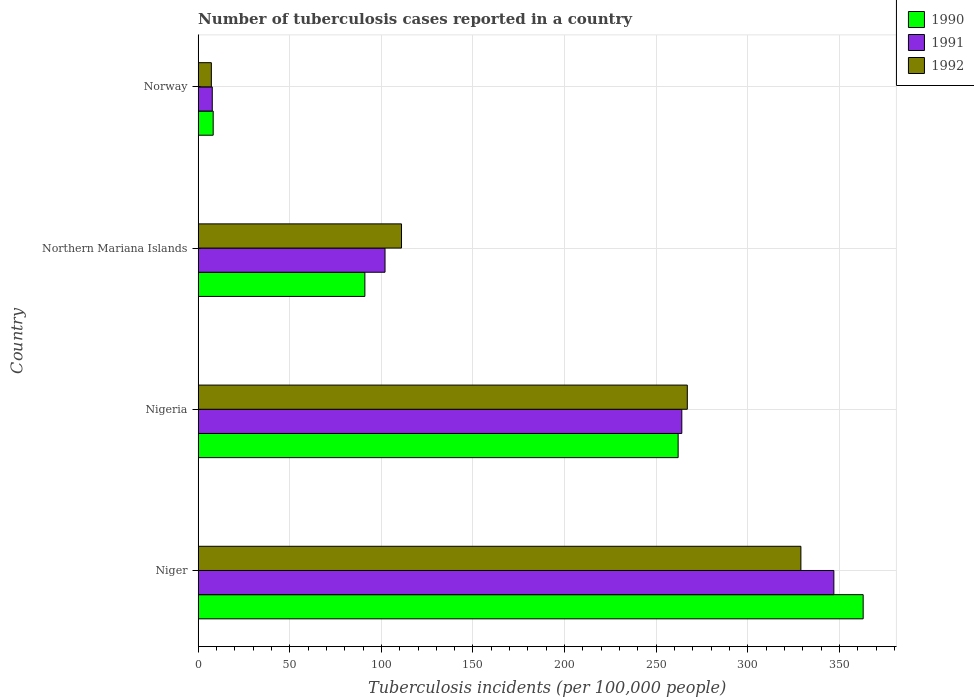How many different coloured bars are there?
Offer a very short reply. 3. Are the number of bars on each tick of the Y-axis equal?
Make the answer very short. Yes. How many bars are there on the 2nd tick from the top?
Offer a very short reply. 3. In how many cases, is the number of bars for a given country not equal to the number of legend labels?
Your response must be concise. 0. What is the number of tuberculosis cases reported in in 1990 in Niger?
Ensure brevity in your answer.  363. Across all countries, what is the maximum number of tuberculosis cases reported in in 1992?
Make the answer very short. 329. In which country was the number of tuberculosis cases reported in in 1992 maximum?
Your answer should be compact. Niger. What is the total number of tuberculosis cases reported in in 1991 in the graph?
Your answer should be very brief. 720.7. What is the difference between the number of tuberculosis cases reported in in 1990 in Northern Mariana Islands and that in Norway?
Offer a terse response. 82.8. What is the difference between the number of tuberculosis cases reported in in 1992 in Northern Mariana Islands and the number of tuberculosis cases reported in in 1990 in Norway?
Offer a very short reply. 102.8. What is the average number of tuberculosis cases reported in in 1990 per country?
Offer a very short reply. 181.05. In how many countries, is the number of tuberculosis cases reported in in 1991 greater than 260 ?
Make the answer very short. 2. What is the ratio of the number of tuberculosis cases reported in in 1990 in Nigeria to that in Northern Mariana Islands?
Offer a very short reply. 2.88. Is the number of tuberculosis cases reported in in 1992 in Nigeria less than that in Northern Mariana Islands?
Your answer should be very brief. No. What is the difference between the highest and the second highest number of tuberculosis cases reported in in 1992?
Your answer should be compact. 62. What is the difference between the highest and the lowest number of tuberculosis cases reported in in 1991?
Your answer should be compact. 339.3. Is the sum of the number of tuberculosis cases reported in in 1991 in Nigeria and Northern Mariana Islands greater than the maximum number of tuberculosis cases reported in in 1992 across all countries?
Keep it short and to the point. Yes. What does the 1st bar from the bottom in Norway represents?
Keep it short and to the point. 1990. How many bars are there?
Offer a terse response. 12. What is the difference between two consecutive major ticks on the X-axis?
Your response must be concise. 50. Does the graph contain any zero values?
Make the answer very short. No. Does the graph contain grids?
Provide a succinct answer. Yes. How many legend labels are there?
Provide a short and direct response. 3. What is the title of the graph?
Make the answer very short. Number of tuberculosis cases reported in a country. Does "2011" appear as one of the legend labels in the graph?
Keep it short and to the point. No. What is the label or title of the X-axis?
Provide a succinct answer. Tuberculosis incidents (per 100,0 people). What is the Tuberculosis incidents (per 100,000 people) of 1990 in Niger?
Ensure brevity in your answer.  363. What is the Tuberculosis incidents (per 100,000 people) of 1991 in Niger?
Keep it short and to the point. 347. What is the Tuberculosis incidents (per 100,000 people) in 1992 in Niger?
Provide a short and direct response. 329. What is the Tuberculosis incidents (per 100,000 people) in 1990 in Nigeria?
Your answer should be very brief. 262. What is the Tuberculosis incidents (per 100,000 people) of 1991 in Nigeria?
Keep it short and to the point. 264. What is the Tuberculosis incidents (per 100,000 people) in 1992 in Nigeria?
Your answer should be very brief. 267. What is the Tuberculosis incidents (per 100,000 people) in 1990 in Northern Mariana Islands?
Your answer should be compact. 91. What is the Tuberculosis incidents (per 100,000 people) in 1991 in Northern Mariana Islands?
Provide a short and direct response. 102. What is the Tuberculosis incidents (per 100,000 people) in 1992 in Northern Mariana Islands?
Keep it short and to the point. 111. What is the Tuberculosis incidents (per 100,000 people) of 1990 in Norway?
Your answer should be very brief. 8.2. What is the Tuberculosis incidents (per 100,000 people) in 1992 in Norway?
Ensure brevity in your answer.  7.2. Across all countries, what is the maximum Tuberculosis incidents (per 100,000 people) in 1990?
Offer a terse response. 363. Across all countries, what is the maximum Tuberculosis incidents (per 100,000 people) in 1991?
Keep it short and to the point. 347. Across all countries, what is the maximum Tuberculosis incidents (per 100,000 people) of 1992?
Your response must be concise. 329. Across all countries, what is the minimum Tuberculosis incidents (per 100,000 people) of 1990?
Offer a very short reply. 8.2. What is the total Tuberculosis incidents (per 100,000 people) in 1990 in the graph?
Offer a terse response. 724.2. What is the total Tuberculosis incidents (per 100,000 people) in 1991 in the graph?
Ensure brevity in your answer.  720.7. What is the total Tuberculosis incidents (per 100,000 people) in 1992 in the graph?
Provide a short and direct response. 714.2. What is the difference between the Tuberculosis incidents (per 100,000 people) of 1990 in Niger and that in Nigeria?
Ensure brevity in your answer.  101. What is the difference between the Tuberculosis incidents (per 100,000 people) of 1991 in Niger and that in Nigeria?
Provide a short and direct response. 83. What is the difference between the Tuberculosis incidents (per 100,000 people) in 1992 in Niger and that in Nigeria?
Your response must be concise. 62. What is the difference between the Tuberculosis incidents (per 100,000 people) in 1990 in Niger and that in Northern Mariana Islands?
Your answer should be very brief. 272. What is the difference between the Tuberculosis incidents (per 100,000 people) of 1991 in Niger and that in Northern Mariana Islands?
Your answer should be very brief. 245. What is the difference between the Tuberculosis incidents (per 100,000 people) in 1992 in Niger and that in Northern Mariana Islands?
Give a very brief answer. 218. What is the difference between the Tuberculosis incidents (per 100,000 people) in 1990 in Niger and that in Norway?
Provide a succinct answer. 354.8. What is the difference between the Tuberculosis incidents (per 100,000 people) of 1991 in Niger and that in Norway?
Offer a terse response. 339.3. What is the difference between the Tuberculosis incidents (per 100,000 people) in 1992 in Niger and that in Norway?
Your answer should be compact. 321.8. What is the difference between the Tuberculosis incidents (per 100,000 people) of 1990 in Nigeria and that in Northern Mariana Islands?
Your answer should be very brief. 171. What is the difference between the Tuberculosis incidents (per 100,000 people) in 1991 in Nigeria and that in Northern Mariana Islands?
Offer a very short reply. 162. What is the difference between the Tuberculosis incidents (per 100,000 people) in 1992 in Nigeria and that in Northern Mariana Islands?
Provide a short and direct response. 156. What is the difference between the Tuberculosis incidents (per 100,000 people) in 1990 in Nigeria and that in Norway?
Your answer should be compact. 253.8. What is the difference between the Tuberculosis incidents (per 100,000 people) in 1991 in Nigeria and that in Norway?
Your answer should be very brief. 256.3. What is the difference between the Tuberculosis incidents (per 100,000 people) of 1992 in Nigeria and that in Norway?
Provide a short and direct response. 259.8. What is the difference between the Tuberculosis incidents (per 100,000 people) of 1990 in Northern Mariana Islands and that in Norway?
Keep it short and to the point. 82.8. What is the difference between the Tuberculosis incidents (per 100,000 people) in 1991 in Northern Mariana Islands and that in Norway?
Your answer should be very brief. 94.3. What is the difference between the Tuberculosis incidents (per 100,000 people) of 1992 in Northern Mariana Islands and that in Norway?
Provide a short and direct response. 103.8. What is the difference between the Tuberculosis incidents (per 100,000 people) of 1990 in Niger and the Tuberculosis incidents (per 100,000 people) of 1991 in Nigeria?
Provide a short and direct response. 99. What is the difference between the Tuberculosis incidents (per 100,000 people) in 1990 in Niger and the Tuberculosis incidents (per 100,000 people) in 1992 in Nigeria?
Offer a terse response. 96. What is the difference between the Tuberculosis incidents (per 100,000 people) in 1990 in Niger and the Tuberculosis incidents (per 100,000 people) in 1991 in Northern Mariana Islands?
Provide a short and direct response. 261. What is the difference between the Tuberculosis incidents (per 100,000 people) in 1990 in Niger and the Tuberculosis incidents (per 100,000 people) in 1992 in Northern Mariana Islands?
Your answer should be very brief. 252. What is the difference between the Tuberculosis incidents (per 100,000 people) of 1991 in Niger and the Tuberculosis incidents (per 100,000 people) of 1992 in Northern Mariana Islands?
Provide a short and direct response. 236. What is the difference between the Tuberculosis incidents (per 100,000 people) of 1990 in Niger and the Tuberculosis incidents (per 100,000 people) of 1991 in Norway?
Keep it short and to the point. 355.3. What is the difference between the Tuberculosis incidents (per 100,000 people) of 1990 in Niger and the Tuberculosis incidents (per 100,000 people) of 1992 in Norway?
Offer a very short reply. 355.8. What is the difference between the Tuberculosis incidents (per 100,000 people) of 1991 in Niger and the Tuberculosis incidents (per 100,000 people) of 1992 in Norway?
Your answer should be compact. 339.8. What is the difference between the Tuberculosis incidents (per 100,000 people) in 1990 in Nigeria and the Tuberculosis incidents (per 100,000 people) in 1991 in Northern Mariana Islands?
Make the answer very short. 160. What is the difference between the Tuberculosis incidents (per 100,000 people) of 1990 in Nigeria and the Tuberculosis incidents (per 100,000 people) of 1992 in Northern Mariana Islands?
Keep it short and to the point. 151. What is the difference between the Tuberculosis incidents (per 100,000 people) of 1991 in Nigeria and the Tuberculosis incidents (per 100,000 people) of 1992 in Northern Mariana Islands?
Your response must be concise. 153. What is the difference between the Tuberculosis incidents (per 100,000 people) of 1990 in Nigeria and the Tuberculosis incidents (per 100,000 people) of 1991 in Norway?
Your answer should be compact. 254.3. What is the difference between the Tuberculosis incidents (per 100,000 people) in 1990 in Nigeria and the Tuberculosis incidents (per 100,000 people) in 1992 in Norway?
Keep it short and to the point. 254.8. What is the difference between the Tuberculosis incidents (per 100,000 people) in 1991 in Nigeria and the Tuberculosis incidents (per 100,000 people) in 1992 in Norway?
Provide a succinct answer. 256.8. What is the difference between the Tuberculosis incidents (per 100,000 people) in 1990 in Northern Mariana Islands and the Tuberculosis incidents (per 100,000 people) in 1991 in Norway?
Provide a short and direct response. 83.3. What is the difference between the Tuberculosis incidents (per 100,000 people) in 1990 in Northern Mariana Islands and the Tuberculosis incidents (per 100,000 people) in 1992 in Norway?
Offer a very short reply. 83.8. What is the difference between the Tuberculosis incidents (per 100,000 people) in 1991 in Northern Mariana Islands and the Tuberculosis incidents (per 100,000 people) in 1992 in Norway?
Offer a very short reply. 94.8. What is the average Tuberculosis incidents (per 100,000 people) of 1990 per country?
Provide a short and direct response. 181.05. What is the average Tuberculosis incidents (per 100,000 people) of 1991 per country?
Make the answer very short. 180.18. What is the average Tuberculosis incidents (per 100,000 people) in 1992 per country?
Ensure brevity in your answer.  178.55. What is the difference between the Tuberculosis incidents (per 100,000 people) in 1990 and Tuberculosis incidents (per 100,000 people) in 1991 in Niger?
Provide a succinct answer. 16. What is the difference between the Tuberculosis incidents (per 100,000 people) in 1990 and Tuberculosis incidents (per 100,000 people) in 1992 in Niger?
Offer a terse response. 34. What is the difference between the Tuberculosis incidents (per 100,000 people) of 1990 and Tuberculosis incidents (per 100,000 people) of 1991 in Nigeria?
Provide a succinct answer. -2. What is the difference between the Tuberculosis incidents (per 100,000 people) of 1991 and Tuberculosis incidents (per 100,000 people) of 1992 in Nigeria?
Provide a short and direct response. -3. What is the difference between the Tuberculosis incidents (per 100,000 people) of 1990 and Tuberculosis incidents (per 100,000 people) of 1991 in Northern Mariana Islands?
Provide a succinct answer. -11. What is the difference between the Tuberculosis incidents (per 100,000 people) in 1991 and Tuberculosis incidents (per 100,000 people) in 1992 in Norway?
Offer a terse response. 0.5. What is the ratio of the Tuberculosis incidents (per 100,000 people) of 1990 in Niger to that in Nigeria?
Provide a succinct answer. 1.39. What is the ratio of the Tuberculosis incidents (per 100,000 people) in 1991 in Niger to that in Nigeria?
Offer a terse response. 1.31. What is the ratio of the Tuberculosis incidents (per 100,000 people) of 1992 in Niger to that in Nigeria?
Provide a succinct answer. 1.23. What is the ratio of the Tuberculosis incidents (per 100,000 people) in 1990 in Niger to that in Northern Mariana Islands?
Offer a terse response. 3.99. What is the ratio of the Tuberculosis incidents (per 100,000 people) of 1991 in Niger to that in Northern Mariana Islands?
Give a very brief answer. 3.4. What is the ratio of the Tuberculosis incidents (per 100,000 people) in 1992 in Niger to that in Northern Mariana Islands?
Offer a terse response. 2.96. What is the ratio of the Tuberculosis incidents (per 100,000 people) in 1990 in Niger to that in Norway?
Give a very brief answer. 44.27. What is the ratio of the Tuberculosis incidents (per 100,000 people) in 1991 in Niger to that in Norway?
Provide a succinct answer. 45.06. What is the ratio of the Tuberculosis incidents (per 100,000 people) of 1992 in Niger to that in Norway?
Your answer should be compact. 45.69. What is the ratio of the Tuberculosis incidents (per 100,000 people) of 1990 in Nigeria to that in Northern Mariana Islands?
Your answer should be compact. 2.88. What is the ratio of the Tuberculosis incidents (per 100,000 people) of 1991 in Nigeria to that in Northern Mariana Islands?
Provide a short and direct response. 2.59. What is the ratio of the Tuberculosis incidents (per 100,000 people) of 1992 in Nigeria to that in Northern Mariana Islands?
Your answer should be compact. 2.41. What is the ratio of the Tuberculosis incidents (per 100,000 people) of 1990 in Nigeria to that in Norway?
Give a very brief answer. 31.95. What is the ratio of the Tuberculosis incidents (per 100,000 people) of 1991 in Nigeria to that in Norway?
Keep it short and to the point. 34.29. What is the ratio of the Tuberculosis incidents (per 100,000 people) in 1992 in Nigeria to that in Norway?
Make the answer very short. 37.08. What is the ratio of the Tuberculosis incidents (per 100,000 people) of 1990 in Northern Mariana Islands to that in Norway?
Your answer should be very brief. 11.1. What is the ratio of the Tuberculosis incidents (per 100,000 people) of 1991 in Northern Mariana Islands to that in Norway?
Your answer should be very brief. 13.25. What is the ratio of the Tuberculosis incidents (per 100,000 people) of 1992 in Northern Mariana Islands to that in Norway?
Give a very brief answer. 15.42. What is the difference between the highest and the second highest Tuberculosis incidents (per 100,000 people) of 1990?
Provide a short and direct response. 101. What is the difference between the highest and the second highest Tuberculosis incidents (per 100,000 people) in 1992?
Keep it short and to the point. 62. What is the difference between the highest and the lowest Tuberculosis incidents (per 100,000 people) in 1990?
Ensure brevity in your answer.  354.8. What is the difference between the highest and the lowest Tuberculosis incidents (per 100,000 people) of 1991?
Provide a succinct answer. 339.3. What is the difference between the highest and the lowest Tuberculosis incidents (per 100,000 people) in 1992?
Your response must be concise. 321.8. 